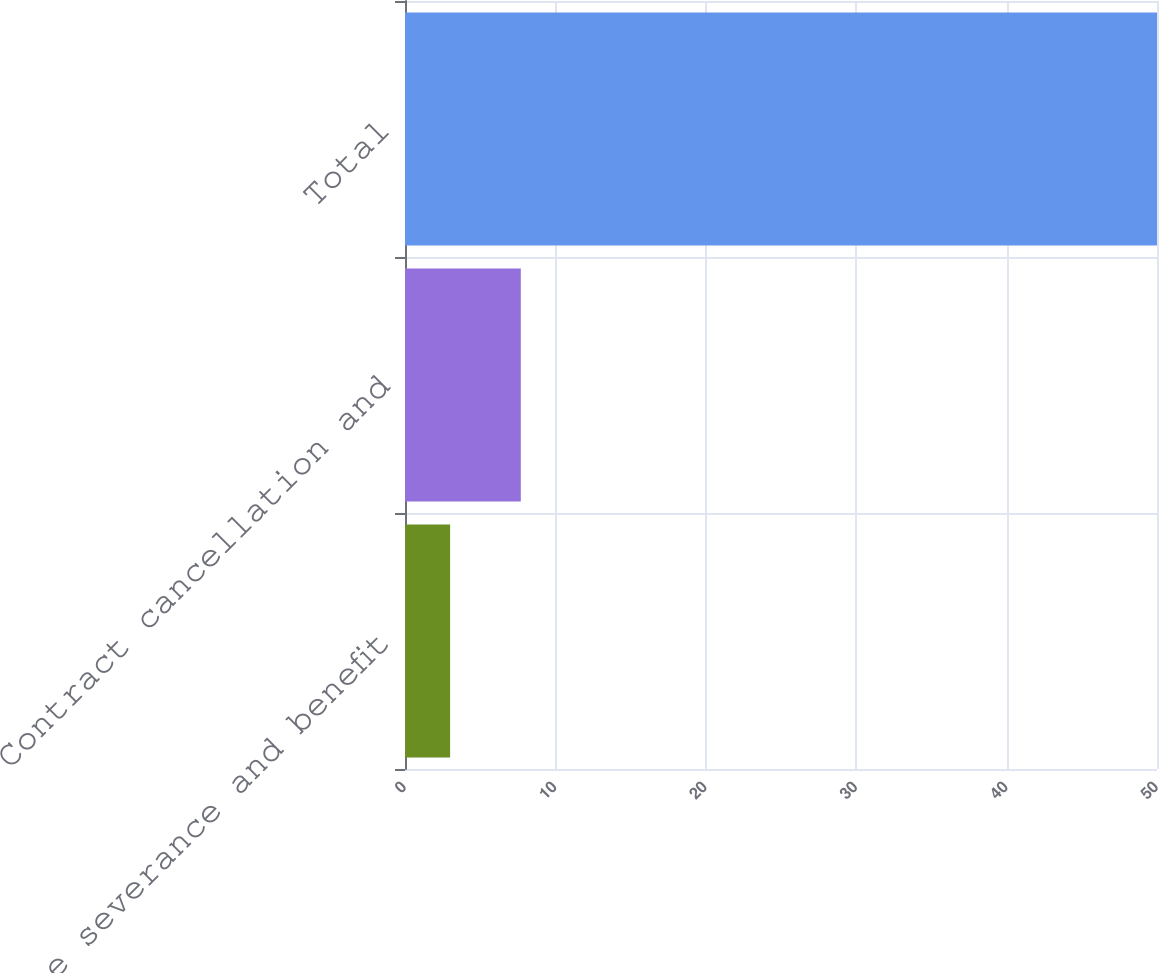Convert chart to OTSL. <chart><loc_0><loc_0><loc_500><loc_500><bar_chart><fcel>Employee severance and benefit<fcel>Contract cancellation and<fcel>Total<nl><fcel>3<fcel>7.7<fcel>50<nl></chart> 